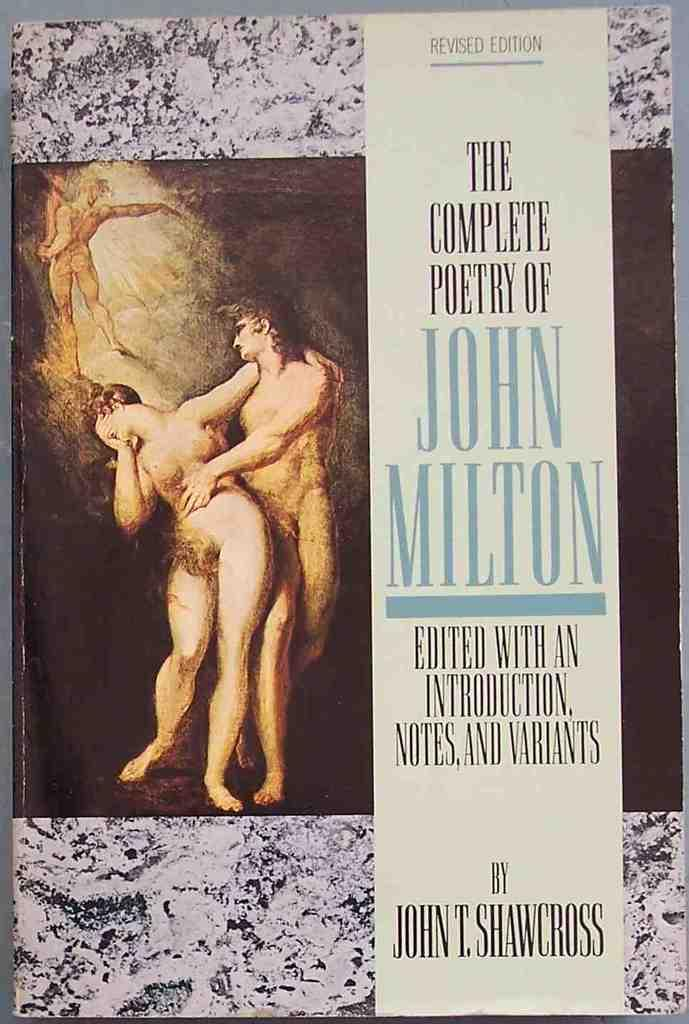Provide a one-sentence caption for the provided image. The title of the book is The Complete Poetry of John Milton. 